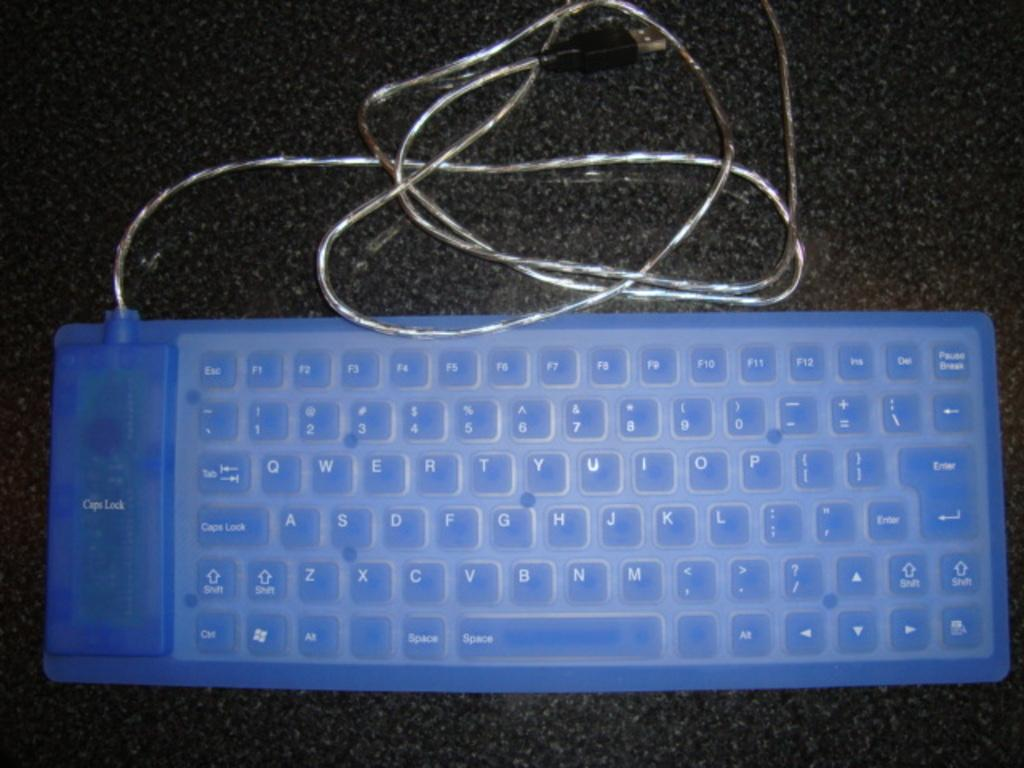<image>
Present a compact description of the photo's key features. a keyboard with a blue keyboard cover over it that says 'caps lock' 